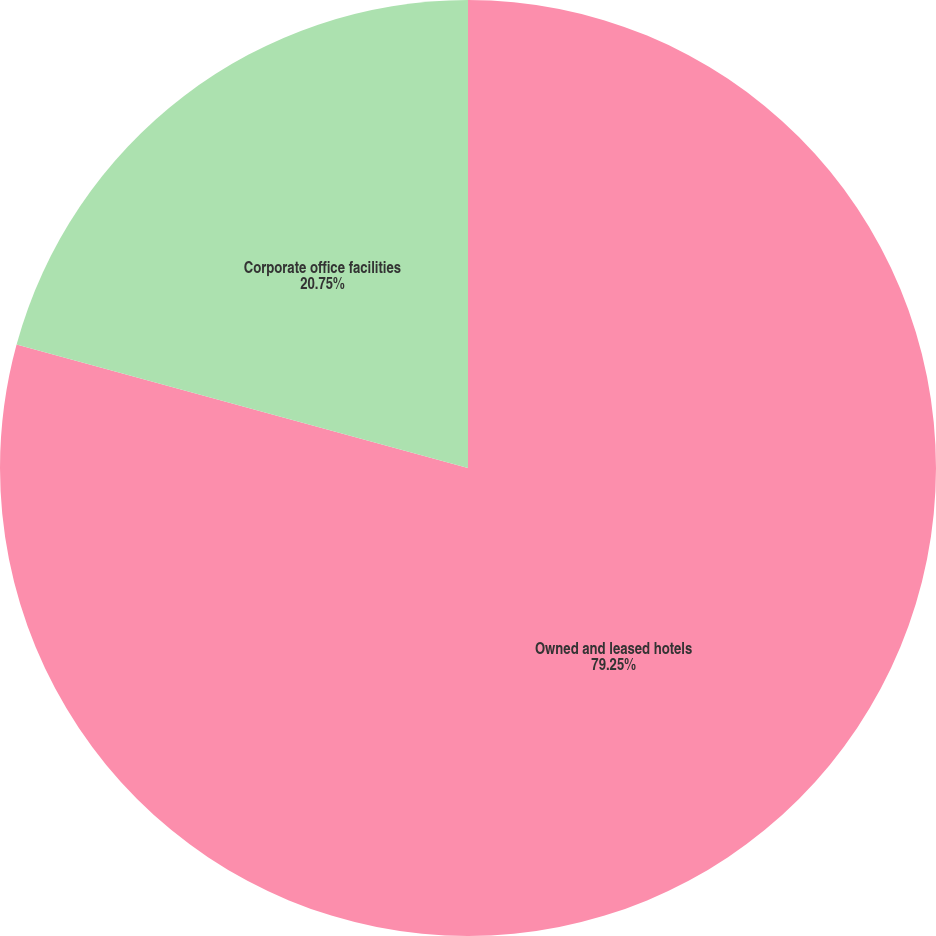Convert chart. <chart><loc_0><loc_0><loc_500><loc_500><pie_chart><fcel>Owned and leased hotels<fcel>Corporate office facilities<nl><fcel>79.25%<fcel>20.75%<nl></chart> 